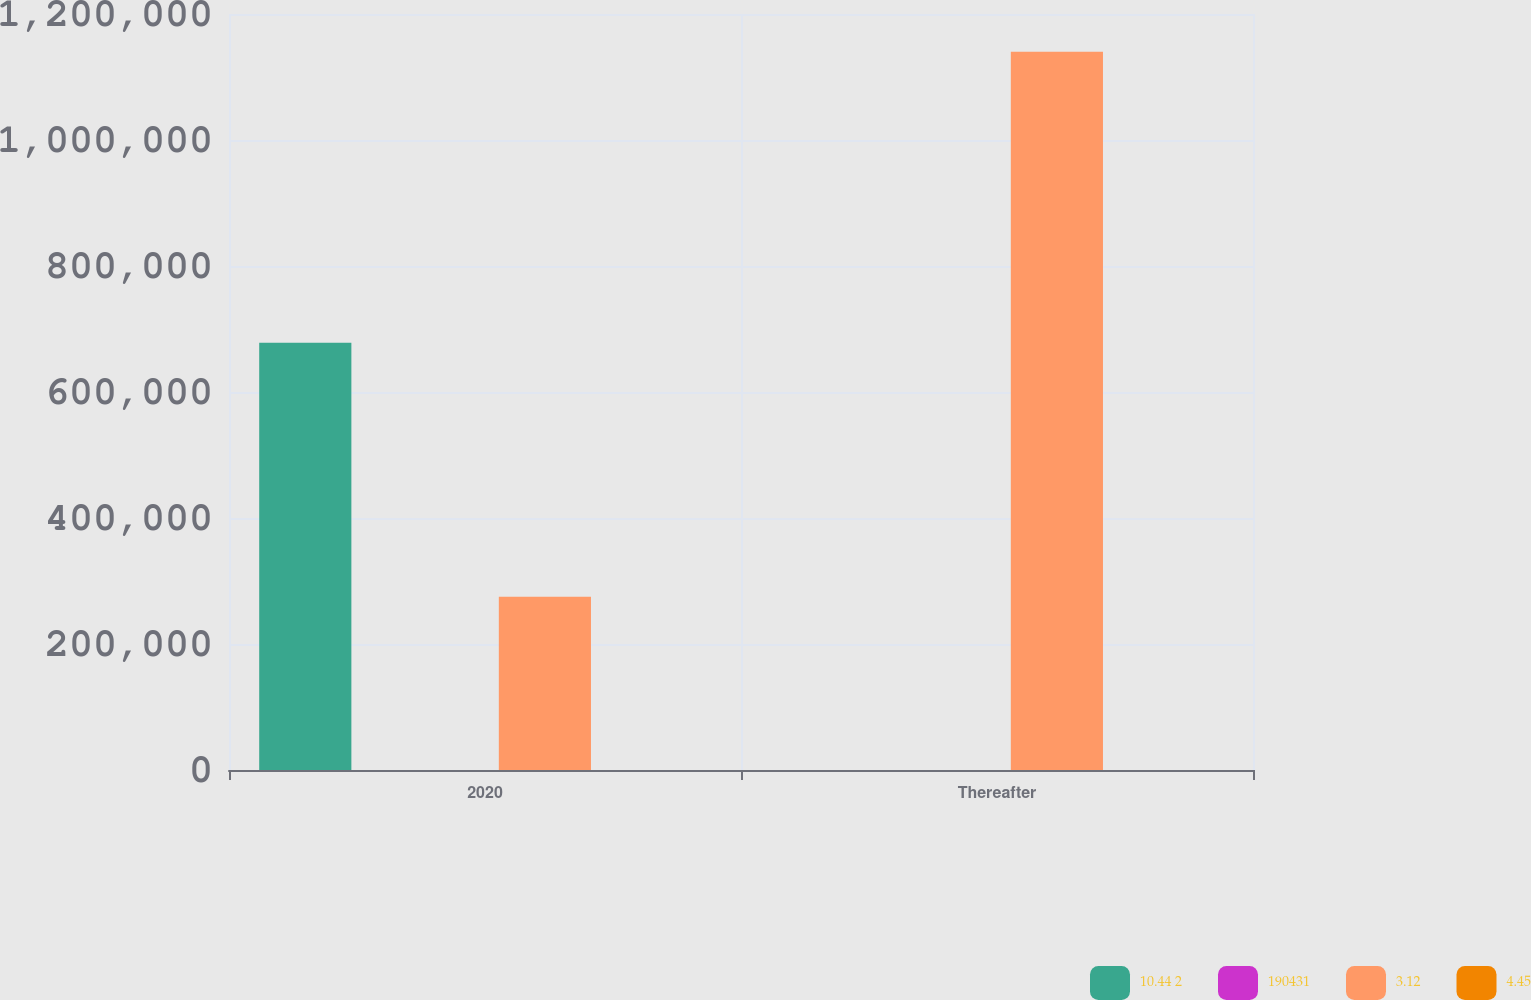Convert chart to OTSL. <chart><loc_0><loc_0><loc_500><loc_500><stacked_bar_chart><ecel><fcel>2020<fcel>Thereafter<nl><fcel>10.44 2<fcel>678018<fcel>4.26<nl><fcel>190431<fcel>4.11<fcel>4.26<nl><fcel>3.12<fcel>275000<fcel>1.14e+06<nl><fcel>4.45<fcel>3.49<fcel>4.14<nl></chart> 